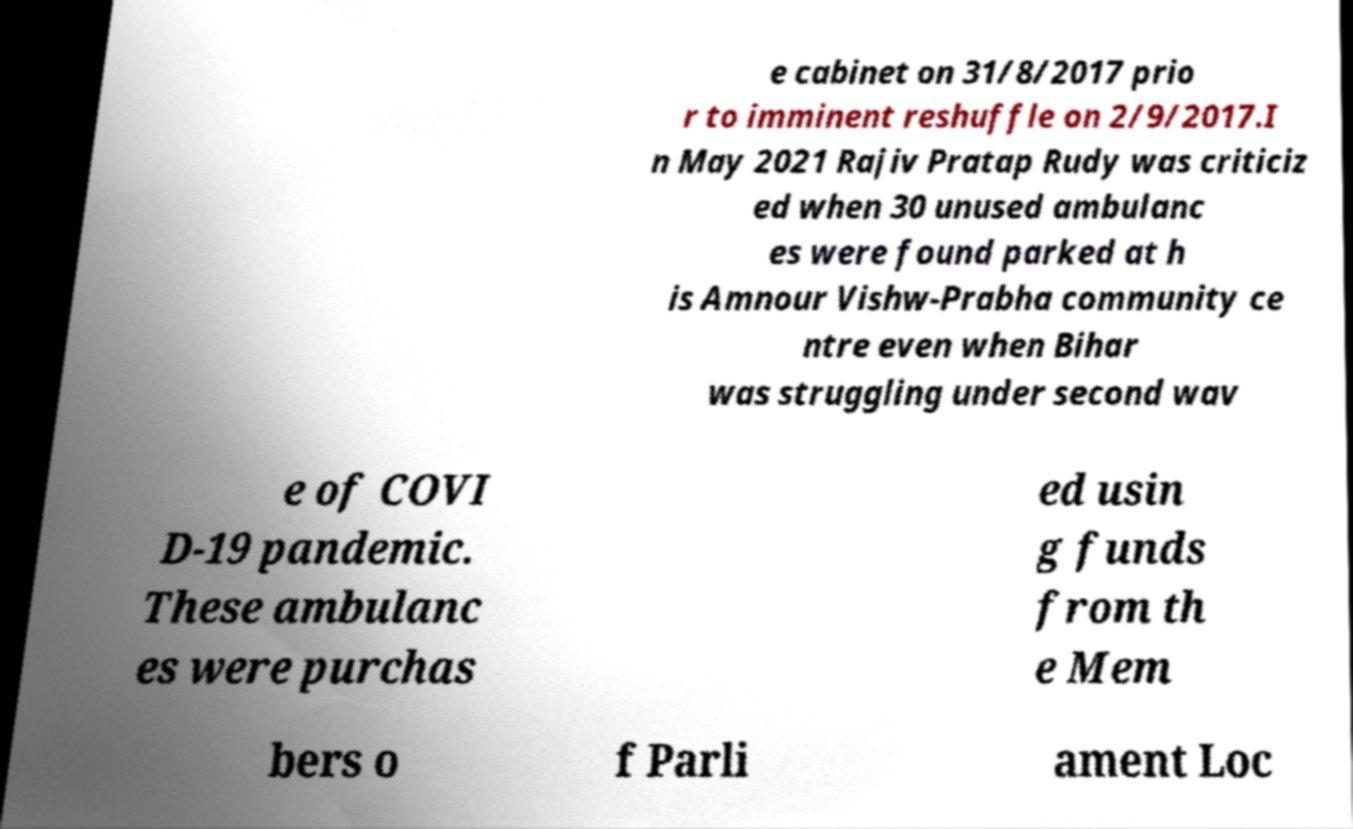Please identify and transcribe the text found in this image. e cabinet on 31/8/2017 prio r to imminent reshuffle on 2/9/2017.I n May 2021 Rajiv Pratap Rudy was criticiz ed when 30 unused ambulanc es were found parked at h is Amnour Vishw-Prabha community ce ntre even when Bihar was struggling under second wav e of COVI D-19 pandemic. These ambulanc es were purchas ed usin g funds from th e Mem bers o f Parli ament Loc 